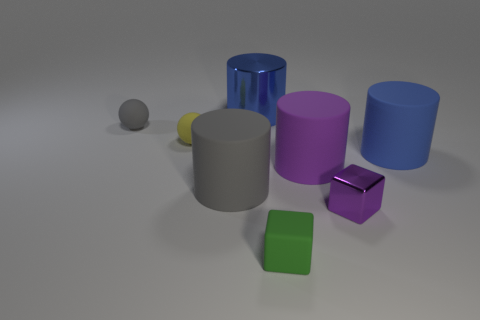What number of other things are there of the same material as the gray cylinder
Provide a short and direct response. 5. How many big objects are either red cylinders or gray matte cylinders?
Provide a succinct answer. 1. Is the material of the small green object the same as the yellow thing?
Your response must be concise. Yes. How many small things are in front of the metal thing that is in front of the big blue rubber cylinder?
Make the answer very short. 1. Is there a blue matte object of the same shape as the tiny purple metallic object?
Ensure brevity in your answer.  No. There is a gray object on the right side of the tiny gray rubber sphere; does it have the same shape as the rubber object that is in front of the large gray object?
Offer a terse response. No. What shape is the tiny rubber thing that is right of the gray sphere and behind the small purple object?
Your answer should be compact. Sphere. Is there another cube that has the same size as the purple block?
Provide a short and direct response. Yes. Is the color of the metal block the same as the tiny ball in front of the tiny gray matte sphere?
Make the answer very short. No. What material is the tiny purple object?
Your answer should be compact. Metal. 